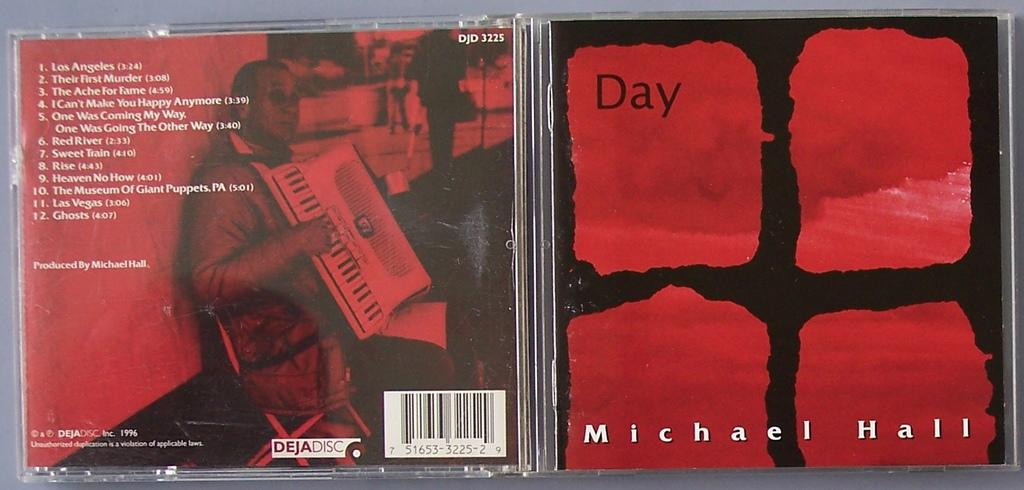<image>
Summarize the visual content of the image. The front and back cover of Michael Hall's  Day CD has a deep red background. 